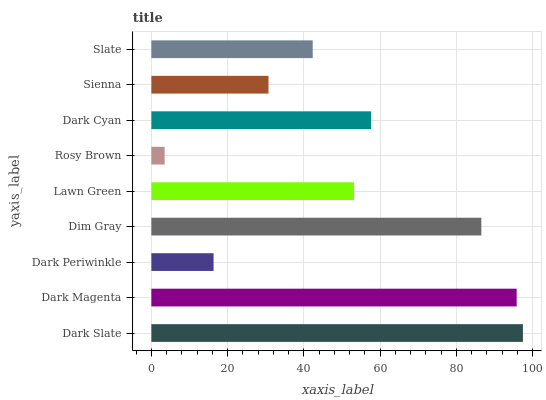Is Rosy Brown the minimum?
Answer yes or no. Yes. Is Dark Slate the maximum?
Answer yes or no. Yes. Is Dark Magenta the minimum?
Answer yes or no. No. Is Dark Magenta the maximum?
Answer yes or no. No. Is Dark Slate greater than Dark Magenta?
Answer yes or no. Yes. Is Dark Magenta less than Dark Slate?
Answer yes or no. Yes. Is Dark Magenta greater than Dark Slate?
Answer yes or no. No. Is Dark Slate less than Dark Magenta?
Answer yes or no. No. Is Lawn Green the high median?
Answer yes or no. Yes. Is Lawn Green the low median?
Answer yes or no. Yes. Is Dark Periwinkle the high median?
Answer yes or no. No. Is Sienna the low median?
Answer yes or no. No. 